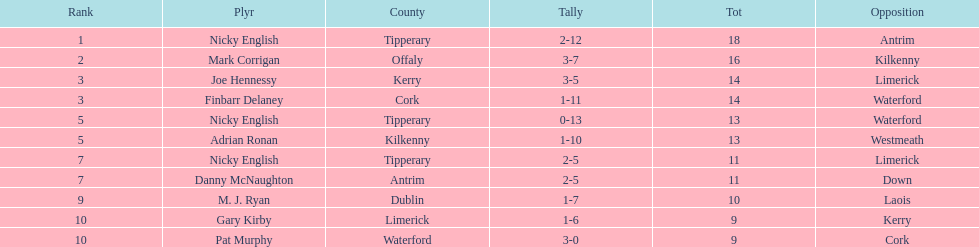Who was the top ranked player in a single game? Nicky English. 